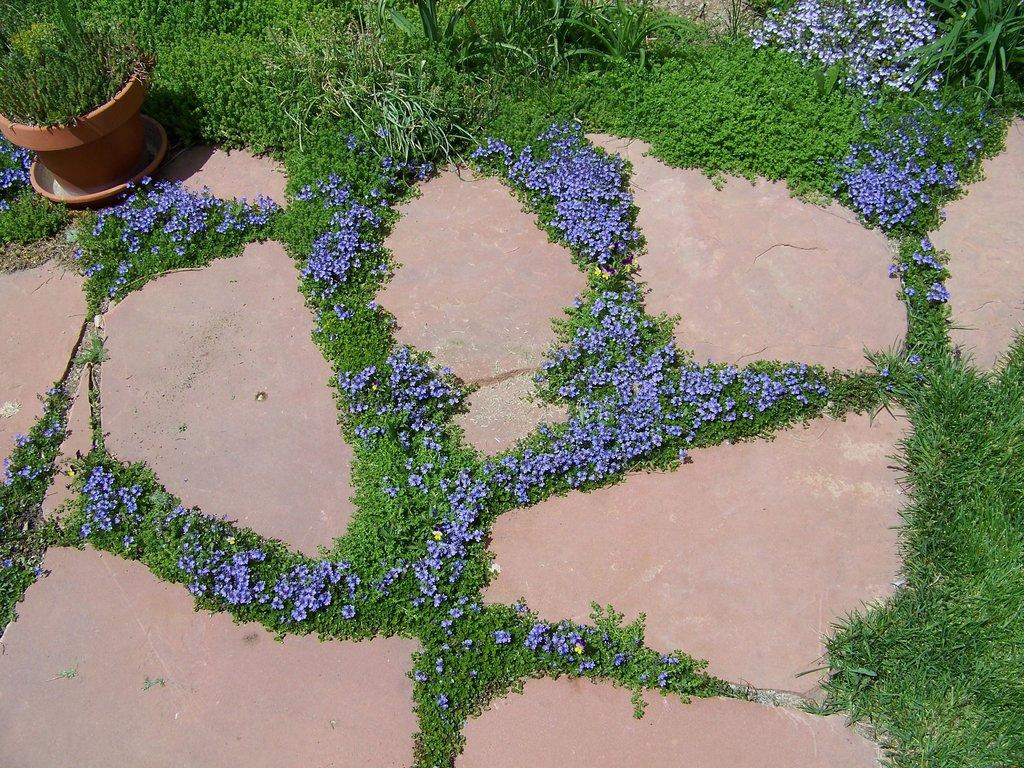What type of vegetation can be seen in the image? There are flowers, tiny plants, and green grass in the image. Where is the plant pot located in the image? The plant pot is on the left side of the image. What type of chain can be seen connecting the books in the image? There are no books or chains present in the image; it features flowers, tiny plants, green grass, and a plant pot. 